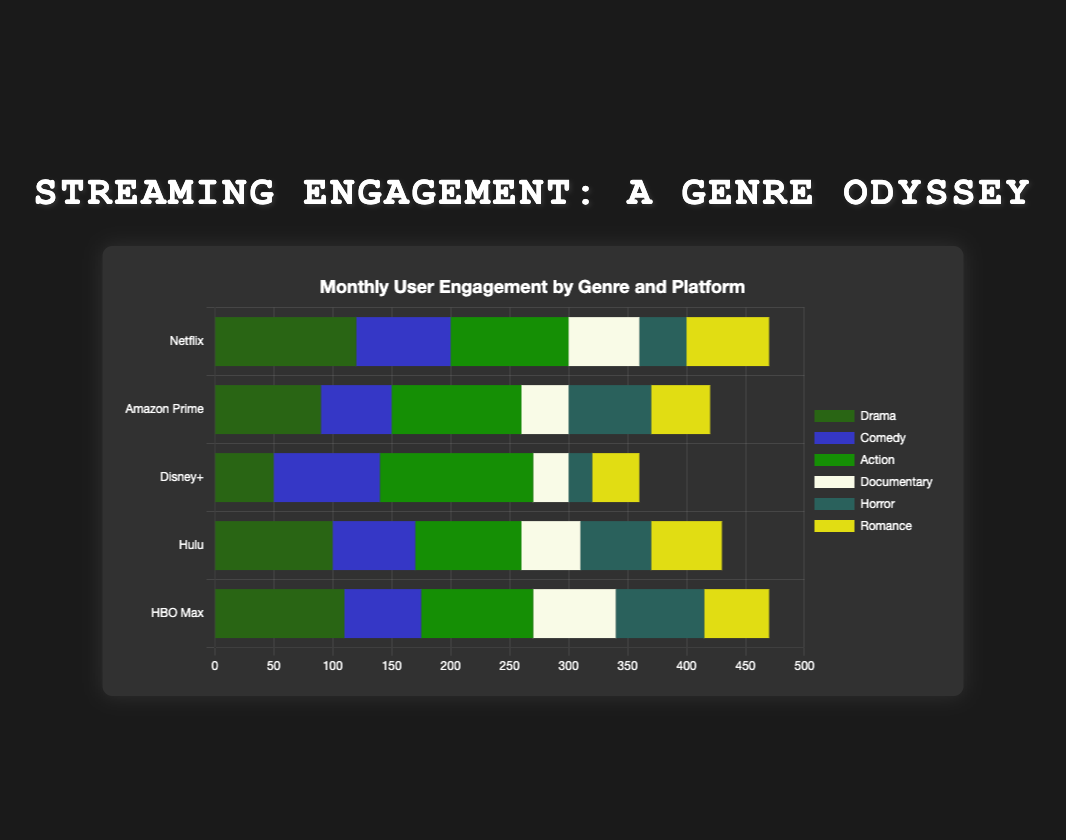Which platform has the highest user engagement for the Action genre? To find this, look at the bar segment labeled "Action" for each platform and compare their lengths. Disney+ has the longest "Action" bar segment with a value of 130.
Answer: Disney+ What is the total user engagement for Drama across all platforms? Sum the values for Drama from all platforms: 120 (Netflix) + 90 (Amazon Prime) + 50 (Disney+) + 100 (Hulu) + 110 (HBO Max) = 470.
Answer: 470 Which platform has the lowest user engagement for Horror? Compare the lengths of the "Horror" segments across platforms. The smallest segment is on Disney+ with a value of 20.
Answer: Disney+ How does Netflix's user engagement in Comedy compare to Hulu's user engagement in Comedy? Compare the lengths of the Comedy segments for Netflix and Hulu. Netflix's Comedy segment is 80, whereas Hulu's Comedy segment is 70, so Netflix has higher engagement.
Answer: Netflix has higher Comedy engagement What is the combined user engagement for Documentary and Horror on Amazon Prime? Add the Documentary and Horror values for Amazon Prime: 40 (Documentary) + 70 (Horror) = 110.
Answer: 110 Which genre has the least user engagement across all platforms? Sum the user engagement values for each genre and find the smallest total. 
Drama: 470, 
Comedy: 365, 
Action: 525, 
Documentary: 250, 
Horror: 265, 
Romance: 275. 
Documentary has the lowest total (250).
Answer: Documentary Which platform has the most balanced user engagement across different genres? To determine this, compare the variability in the lengths of segments for each platform. Hulu's segments appear the most balanced with values ranging closely together without extreme highs or lows: Drama (100), Comedy (70), Action (90), Documentary (50), Horror (60), Romance (60).
Answer: Hulu What is the difference in user engagement between Drama and Action genres on HBO Max? Subtract the Action engagement from the Drama engagement on HBO Max: 110 (Drama) - 95 (Action) = 15.
Answer: 15 How does the total user engagement for Netflix compare to the total user engagement for HBO Max? Sum all genre values for Netflix and HBO Max and compare. 
Netflix: 120 (Drama) + 80 (Comedy) + 100 (Action) + 60 (Documentary) + 40 (Horror) + 70 (Romance) = 470, 
HBO Max: 110 (Drama) + 65 (Comedy) + 95 (Action) + 70 (Documentary) + 75 (Horror) + 55 (Romance) = 470. 
Both platforms have the same total engagement.
Answer: Same What is the average user engagement per genre on Disney+? Sum all genre values for Disney+ and divide by the number of genres: (50 + 90 + 130 + 30 + 20 + 40) / 6 = 60.
Answer: 60 